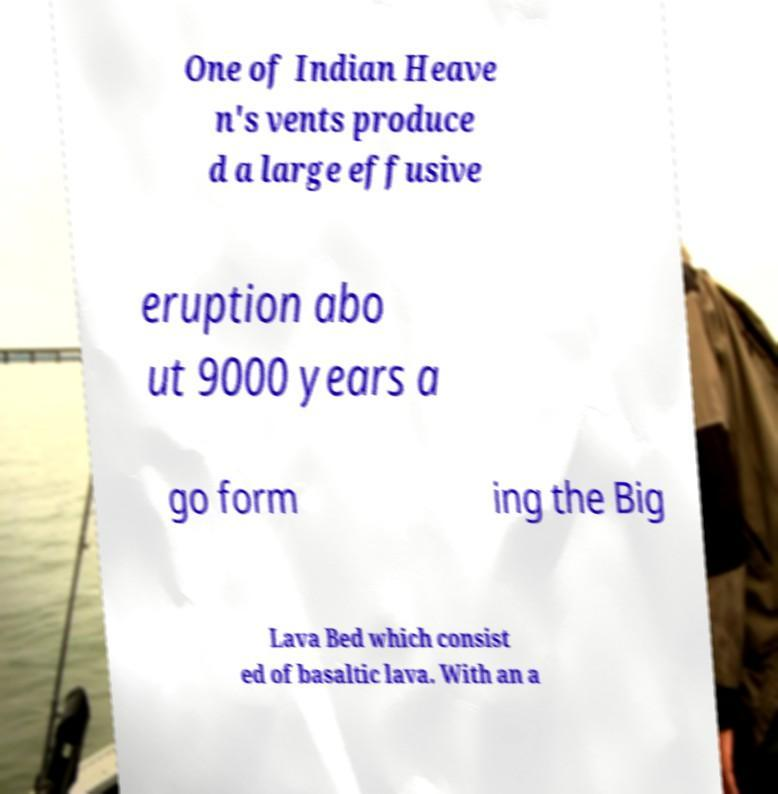For documentation purposes, I need the text within this image transcribed. Could you provide that? One of Indian Heave n's vents produce d a large effusive eruption abo ut 9000 years a go form ing the Big Lava Bed which consist ed of basaltic lava. With an a 